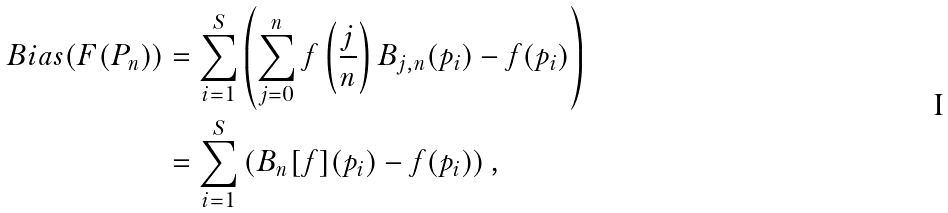Convert formula to latex. <formula><loc_0><loc_0><loc_500><loc_500>B i a s ( F ( P _ { n } ) ) & = \sum _ { i = 1 } ^ { S } \left ( \sum _ { j = 0 } ^ { n } f \left ( \frac { j } { n } \right ) B _ { j , n } ( p _ { i } ) - f ( p _ { i } ) \right ) \\ & = \sum _ { i = 1 } ^ { S } \left ( B _ { n } [ f ] ( p _ { i } ) - f ( p _ { i } ) \right ) ,</formula> 